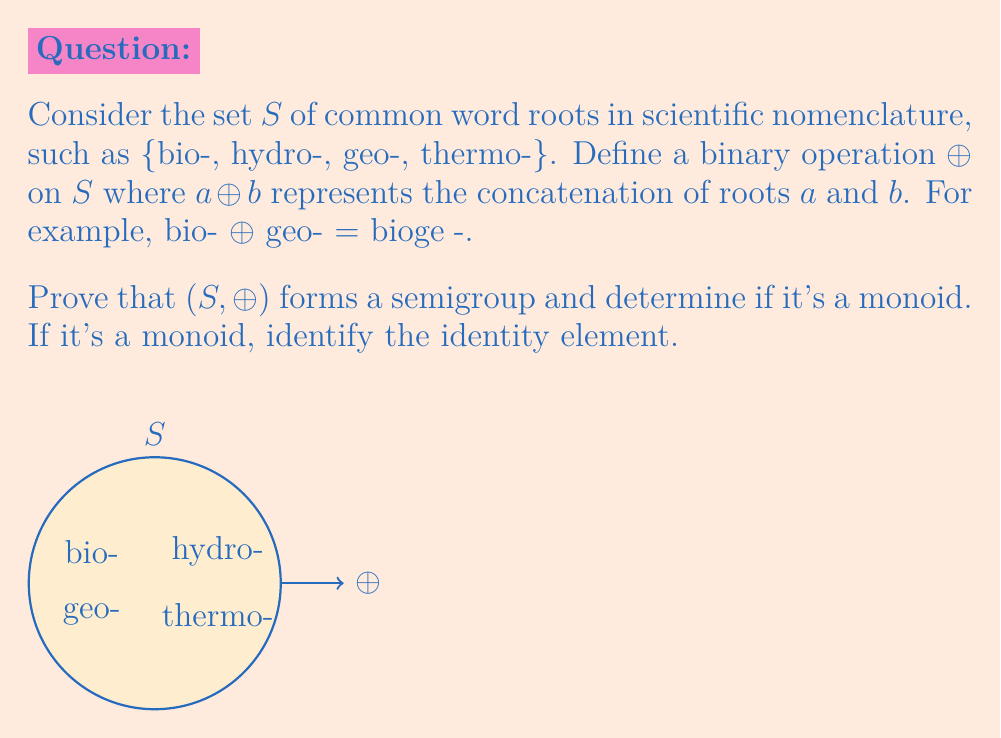Help me with this question. Let's approach this step-by-step:

1) To prove $(S, \oplus)$ is a semigroup, we need to show that $\oplus$ is associative.

2) For any $a, b, c \in S$:
   $(a \oplus b) \oplus c = (ab) \oplus c = abc$
   $a \oplus (b \oplus c) = a \oplus (bc) = abc$

   Since concatenation of strings is associative, $\oplus$ is associative.

3) Therefore, $(S, \oplus)$ is a semigroup.

4) To be a monoid, $(S, \oplus)$ must have an identity element $e$ such that $e \oplus a = a \oplus e = a$ for all $a \in S$.

5) In this case, an empty string "" could serve as the identity element:
   "" $\oplus$ bio- = bio- $\oplus$ "" = bio-

6) However, the empty string is not included in the given set $S$. Without adding it to $S$, there is no identity element.

7) Therefore, $(S, \oplus)$ is not a monoid as defined.

8) If we were to add the empty string to $S$, then it would become a monoid with "" as the identity element.
Answer: $(S, \oplus)$ is a semigroup but not a monoid. 